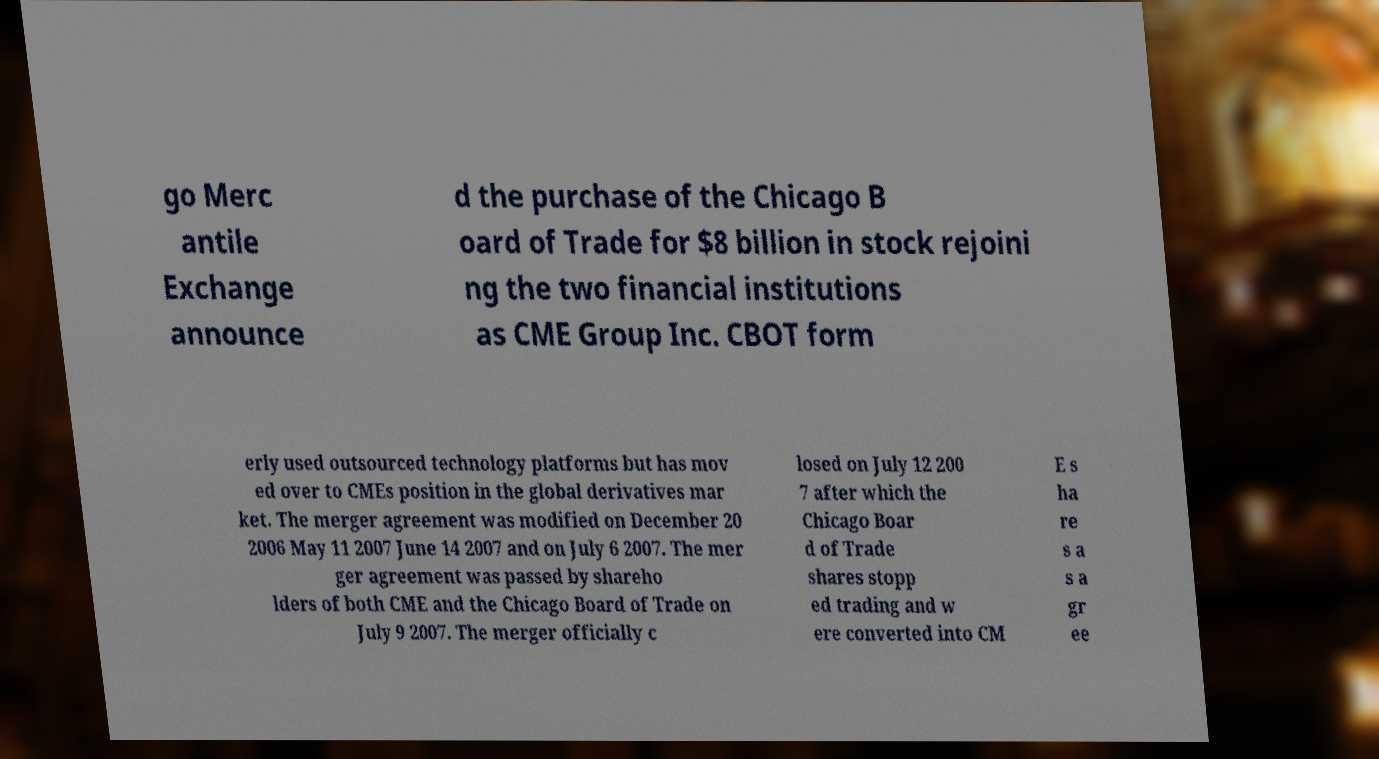There's text embedded in this image that I need extracted. Can you transcribe it verbatim? go Merc antile Exchange announce d the purchase of the Chicago B oard of Trade for $8 billion in stock rejoini ng the two financial institutions as CME Group Inc. CBOT form erly used outsourced technology platforms but has mov ed over to CMEs position in the global derivatives mar ket. The merger agreement was modified on December 20 2006 May 11 2007 June 14 2007 and on July 6 2007. The mer ger agreement was passed by shareho lders of both CME and the Chicago Board of Trade on July 9 2007. The merger officially c losed on July 12 200 7 after which the Chicago Boar d of Trade shares stopp ed trading and w ere converted into CM E s ha re s a s a gr ee 